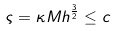Convert formula to latex. <formula><loc_0><loc_0><loc_500><loc_500>\varsigma = \kappa M h ^ { \frac { 3 } { 2 } } \leq c</formula> 